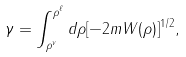<formula> <loc_0><loc_0><loc_500><loc_500>\gamma = \int _ { \rho ^ { v } } ^ { \rho ^ { \ell } } d \rho [ - 2 m W ( \rho ) ] ^ { 1 / 2 } ,</formula> 